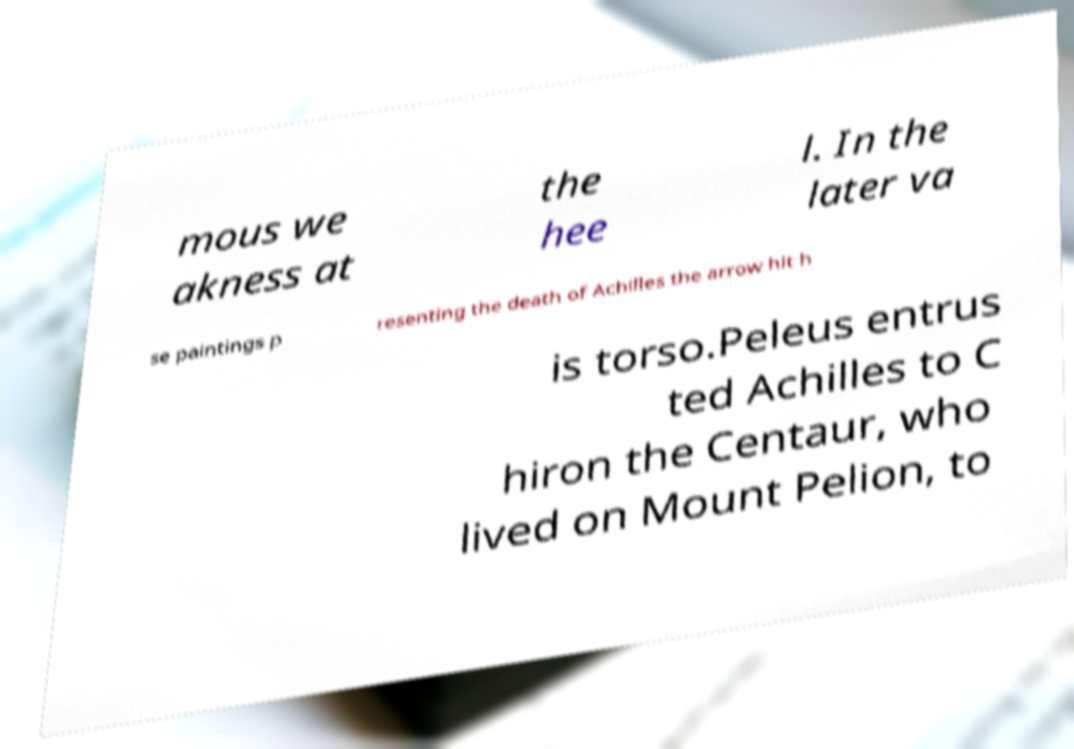Please read and relay the text visible in this image. What does it say? mous we akness at the hee l. In the later va se paintings p resenting the death of Achilles the arrow hit h is torso.Peleus entrus ted Achilles to C hiron the Centaur, who lived on Mount Pelion, to 